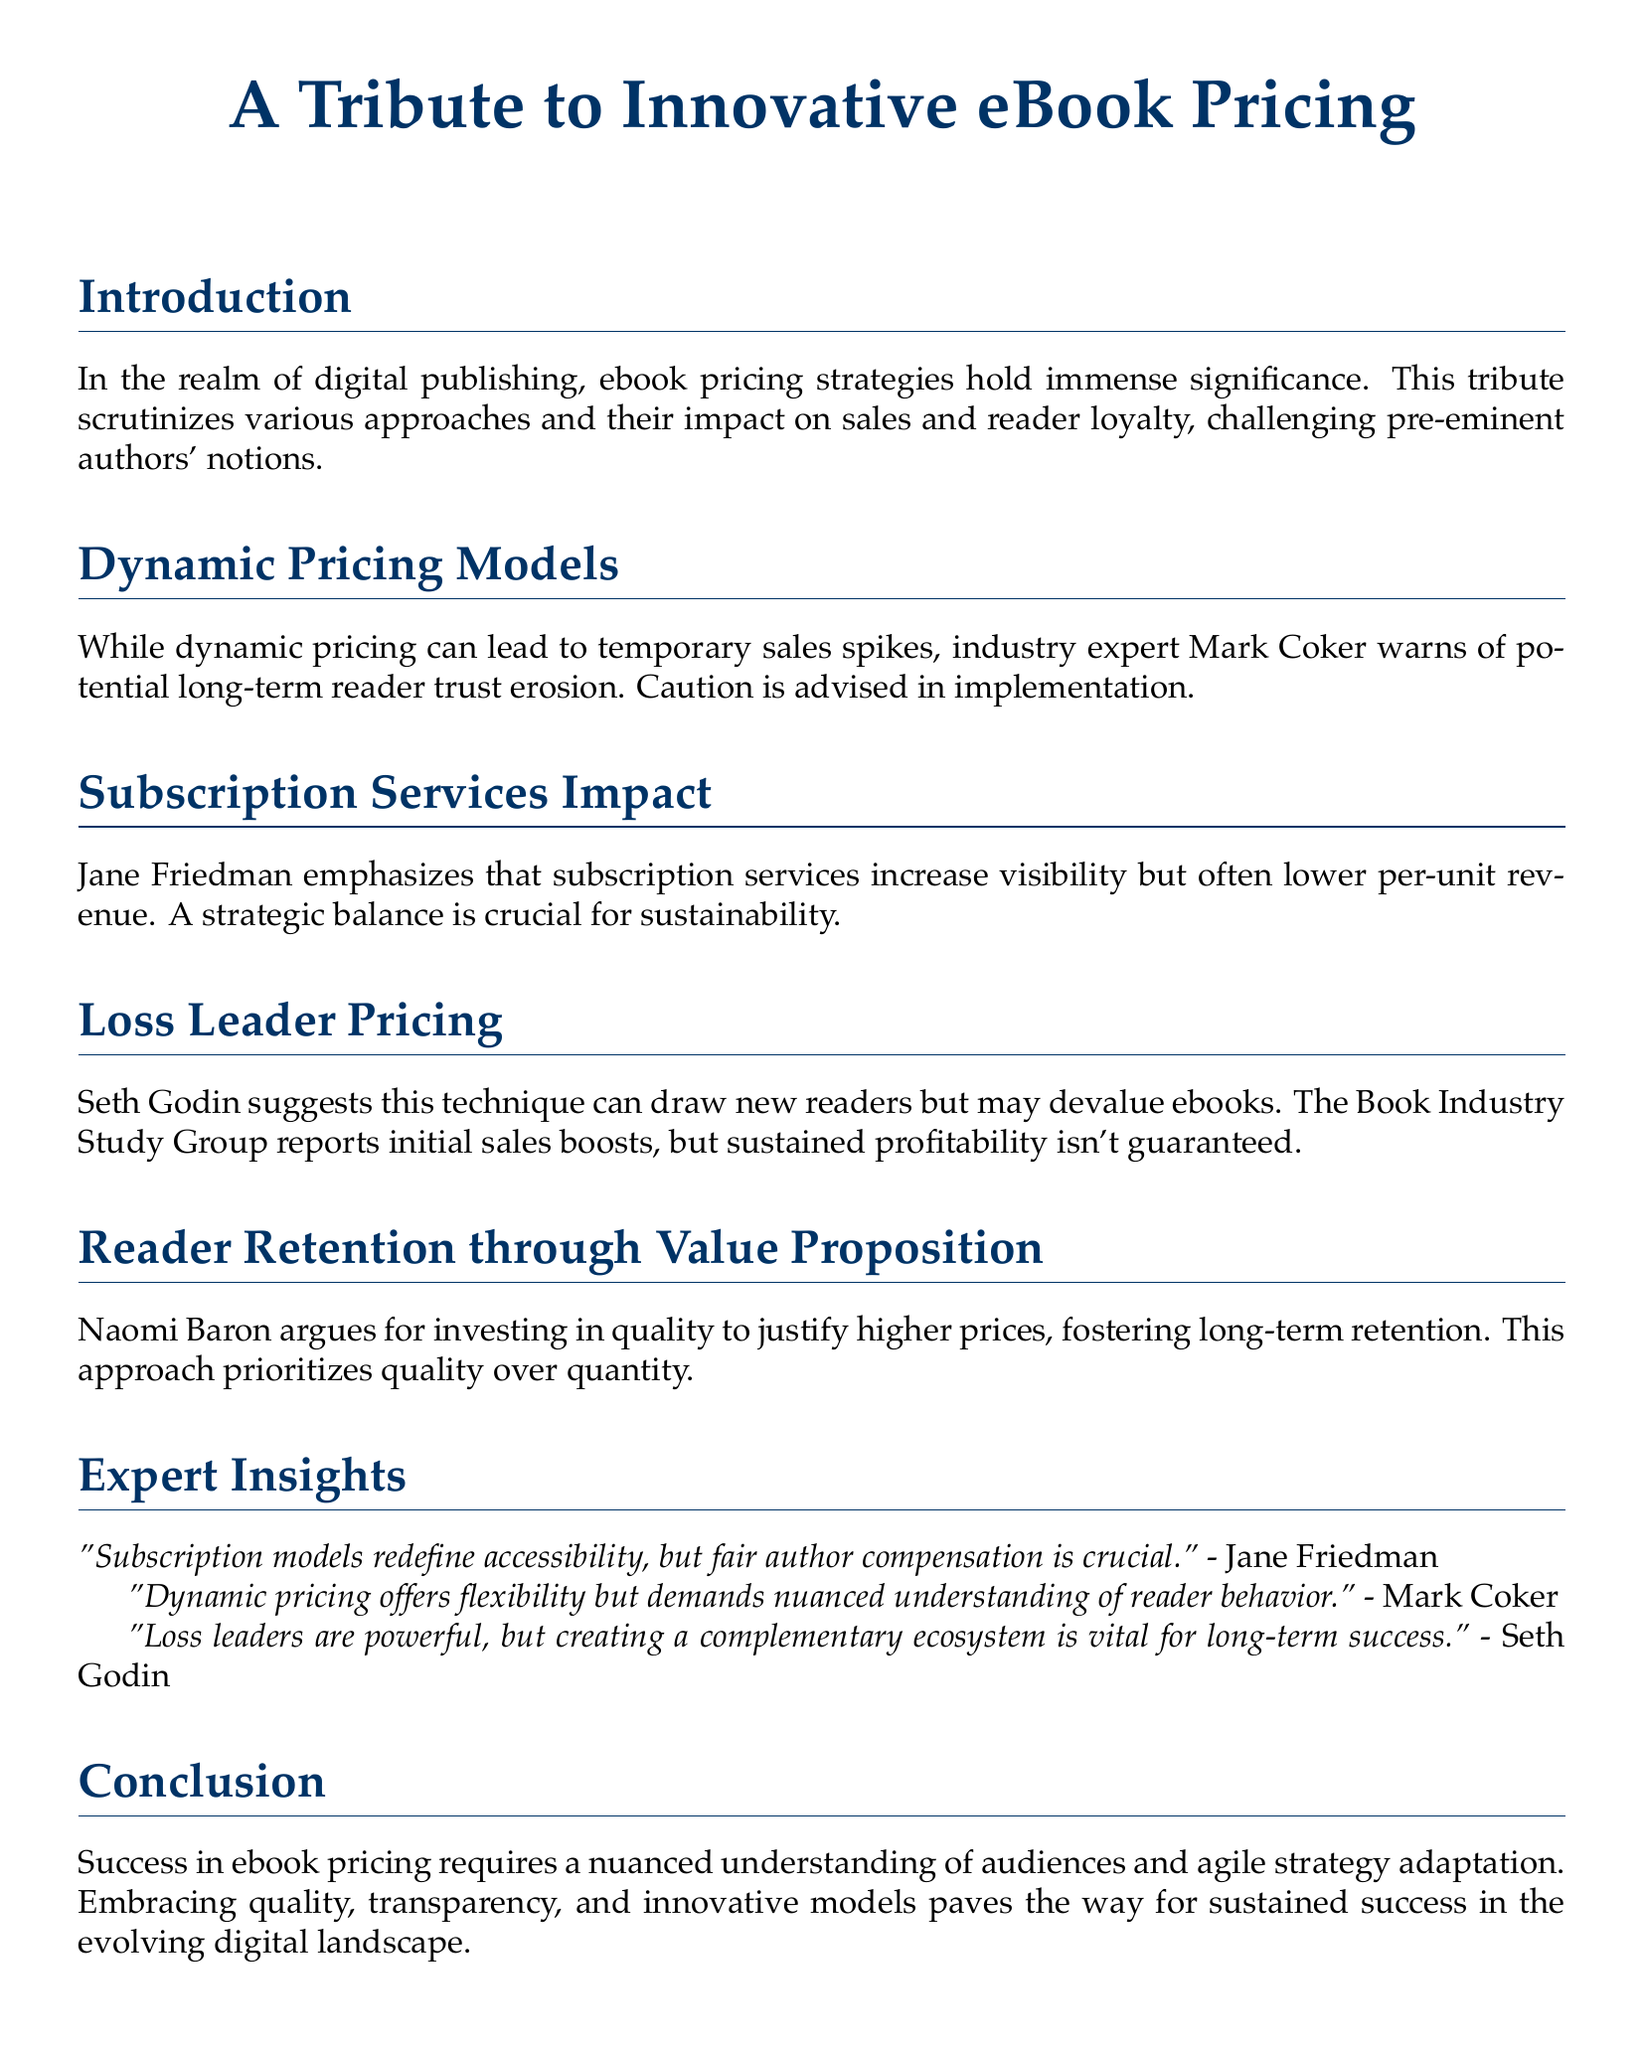What is the title of the document? The title of the document is prominently displayed at the top, indicating its focus on ebook pricing.
Answer: A Tribute to Innovative eBook Pricing Who provided insights on subscription services? The document attributes thoughts on subscription services to industry expert Jane Friedman.
Answer: Jane Friedman What pricing strategy did Seth Godin discuss? Seth Godin's perspective within the document centers on a specific pricing strategy known as a loss leader.
Answer: Loss Leader Pricing What is a potential risk of dynamic pricing mentioned? The document notes that dynamic pricing can lead to a specific detrimental effect on reader trust over time.
Answer: Trust erosion Which expert emphasizes quality for reader retention? Within the analysis, Naomi Baron is the expert who highlights the importance of quality for retaining readers.
Answer: Naomi Baron How does the document suggest achieving long-term success? The conclusion advocates for a multifaceted approach focused on a combination of elements for sustained success in ebook pricing.
Answer: Quality, transparency, and innovative models What is a potential downside of subscription services? The document mentions a specific consequence of subscription services related to the revenue generated per unit sold.
Answer: Lower per-unit revenue Which approach prioritizes quality over quantity? The text asserts that a certain pricing strategy focuses more on the caliber of ebooks rather than the total amount of offerings.
Answer: Value Proposition 